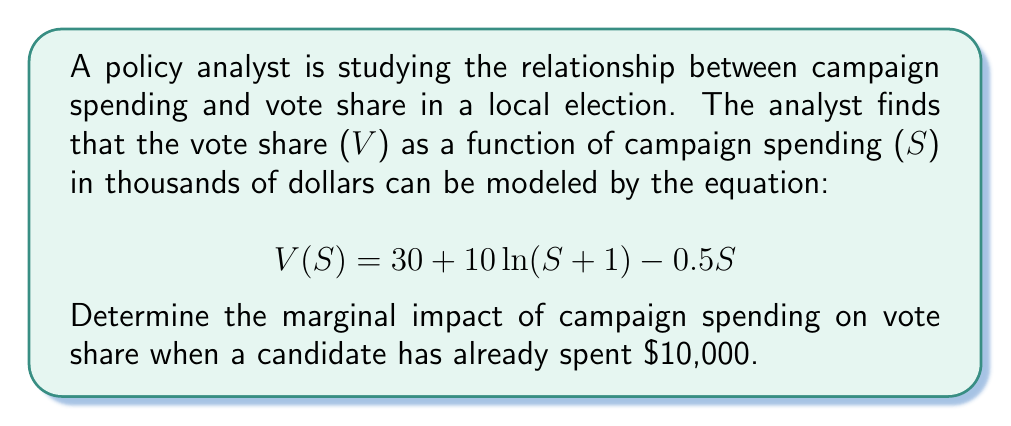Show me your answer to this math problem. To find the marginal impact of campaign spending on vote share, we need to calculate the derivative of the vote share function V(S) with respect to S and evaluate it at S = 10.

Step 1: Calculate the derivative of V(S).
$$\frac{dV}{dS} = \frac{d}{dS}[30 + 10\ln(S + 1) - 0.5S]$$
$$\frac{dV}{dS} = 10 \cdot \frac{1}{S + 1} - 0.5$$

Step 2: Evaluate the derivative at S = 10.
$$\frac{dV}{dS}\bigg|_{S=10} = 10 \cdot \frac{1}{10 + 1} - 0.5$$
$$\frac{dV}{dS}\bigg|_{S=10} = \frac{10}{11} - 0.5$$
$$\frac{dV}{dS}\bigg|_{S=10} = \frac{10}{11} - \frac{11}{22} = \frac{20}{22} - \frac{11}{22} = \frac{9}{22} \approx 0.4091$$

Step 3: Interpret the result.
The marginal impact of campaign spending on vote share when a candidate has already spent $10,000 is approximately 0.4091 percentage points per thousand dollars spent. This means that for each additional $1,000 spent on the campaign, the candidate can expect their vote share to increase by about 0.4091 percentage points.
Answer: $\frac{9}{22}$ or approximately 0.4091 percentage points per $1,000 spent 